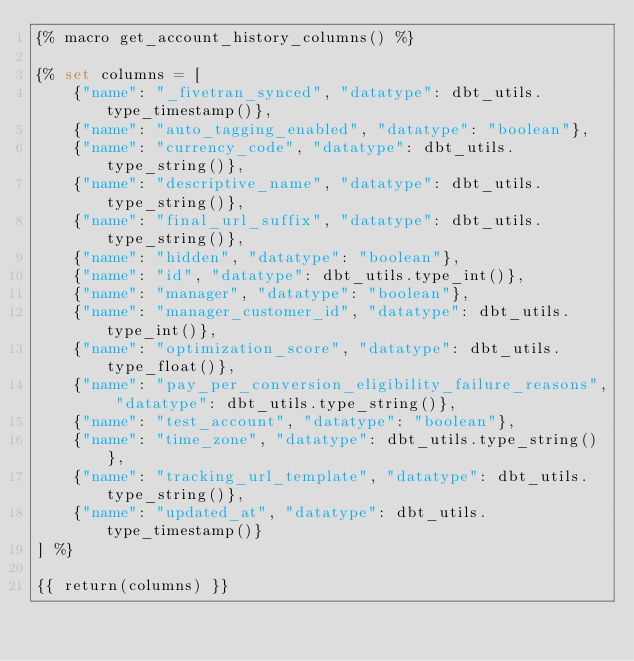<code> <loc_0><loc_0><loc_500><loc_500><_SQL_>{% macro get_account_history_columns() %}

{% set columns = [
    {"name": "_fivetran_synced", "datatype": dbt_utils.type_timestamp()},
    {"name": "auto_tagging_enabled", "datatype": "boolean"},
    {"name": "currency_code", "datatype": dbt_utils.type_string()},
    {"name": "descriptive_name", "datatype": dbt_utils.type_string()},
    {"name": "final_url_suffix", "datatype": dbt_utils.type_string()},
    {"name": "hidden", "datatype": "boolean"},
    {"name": "id", "datatype": dbt_utils.type_int()},
    {"name": "manager", "datatype": "boolean"},
    {"name": "manager_customer_id", "datatype": dbt_utils.type_int()},
    {"name": "optimization_score", "datatype": dbt_utils.type_float()},
    {"name": "pay_per_conversion_eligibility_failure_reasons", "datatype": dbt_utils.type_string()},
    {"name": "test_account", "datatype": "boolean"},
    {"name": "time_zone", "datatype": dbt_utils.type_string()},
    {"name": "tracking_url_template", "datatype": dbt_utils.type_string()},
    {"name": "updated_at", "datatype": dbt_utils.type_timestamp()}
] %}

{{ return(columns) }}
</code> 